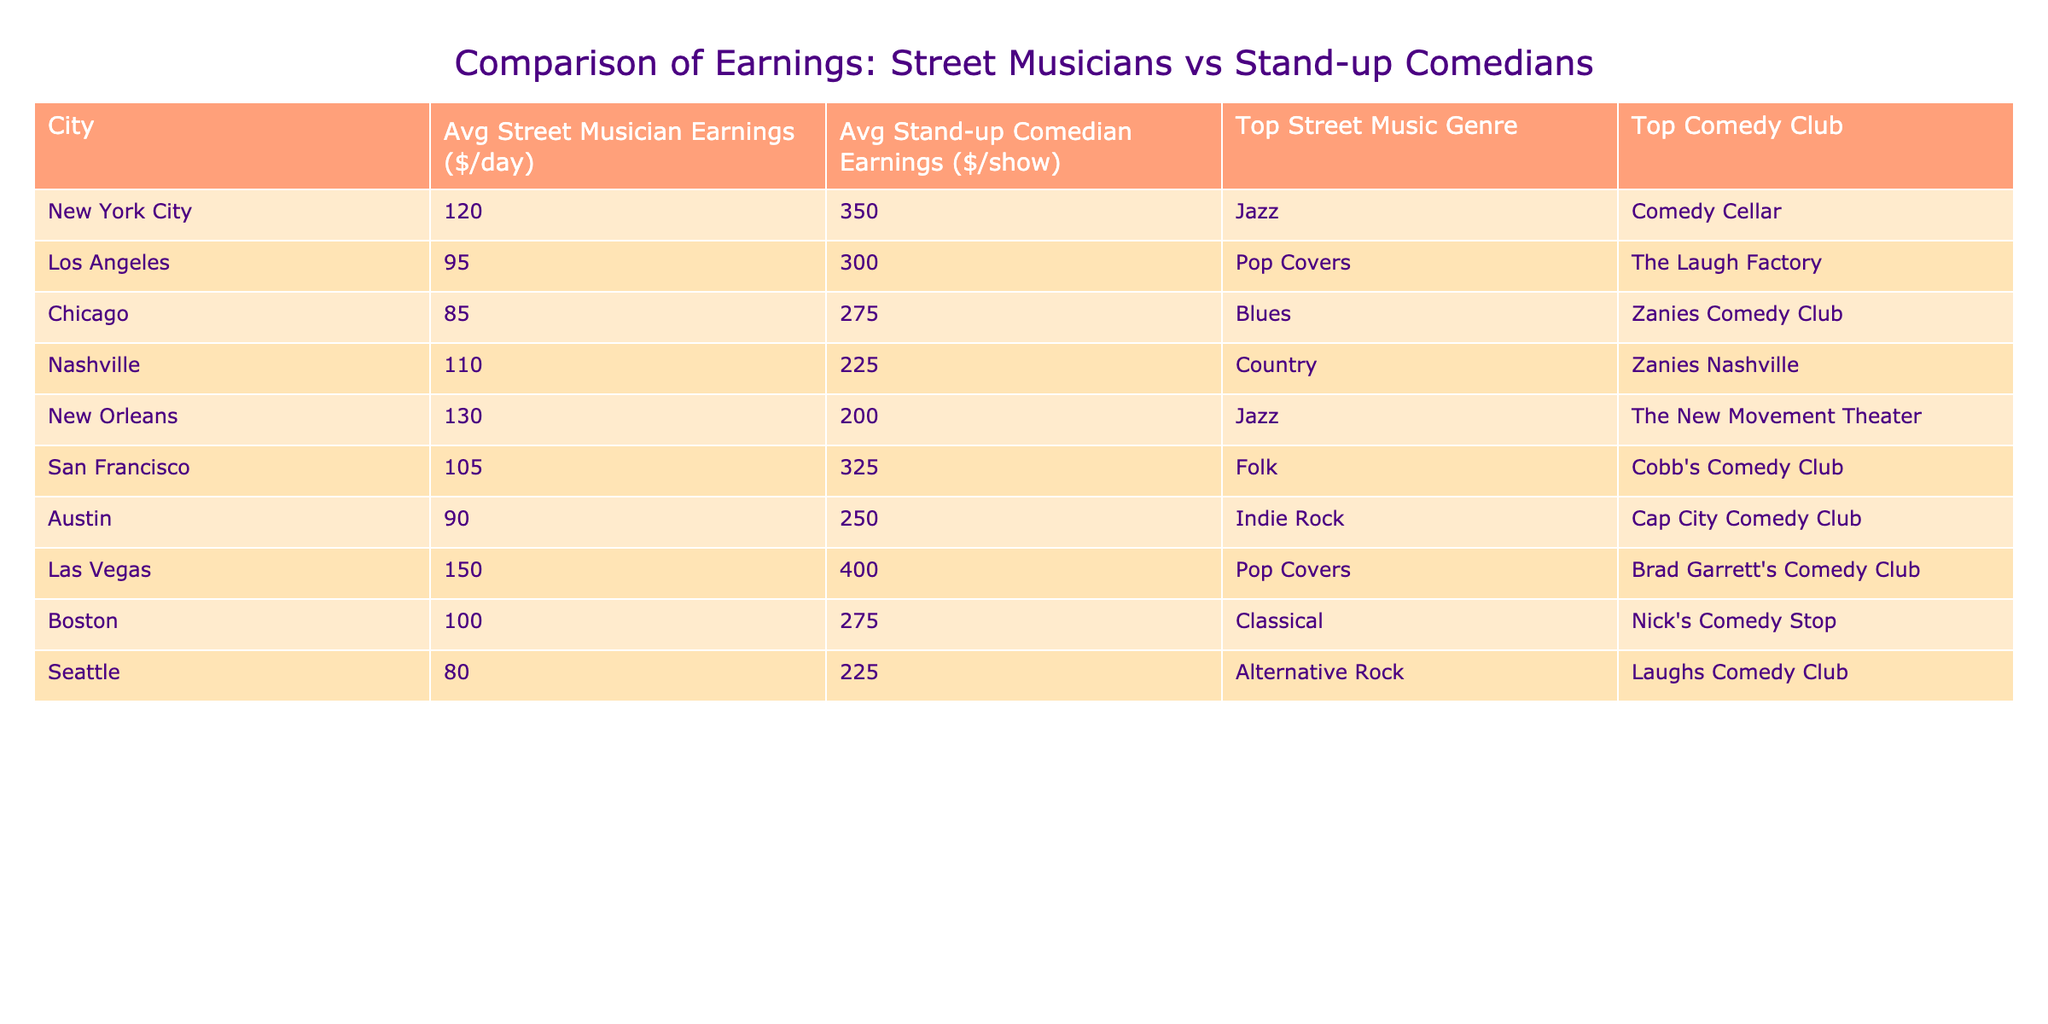What is the average earnings of street musicians in Los Angeles? According to the table, the average earnings of street musicians in Los Angeles is listed as $95 per day.
Answer: 95 Which city has the highest average earnings for stand-up comedians? By looking at the table, Las Vegas shows the highest average earnings for stand-up comedians at $400 per show.
Answer: 400 Is the top street music genre in New Orleans Jazz? The table indicates that the top street music genre in New Orleans is indeed Jazz, confirmed by the data listed.
Answer: Yes What is the difference in average earnings between street musicians in New York City and Chicago? The average earnings for street musicians in New York City is $120, and in Chicago, it is $85. The difference is 120 - 85 = 35.
Answer: 35 Which genre do street musicians in Nashville typically play? According to the table, the top street music genre in Nashville is Country, as stated in the data provided.
Answer: Country Calculate the average earnings of street musicians across all cities listed. Summing the average earnings: 120 + 95 + 85 + 110 + 130 + 105 + 90 + 150 + 100 + 80 = 1,025. There are 10 cities, so the average is 1,025 / 10 = 102.5.
Answer: 102.5 Is there a city where the average earnings of street musicians are greater than $100? The table shows that the average earnings of street musicians in New York City, Nashville, New Orleans, and Las Vegas are all above $100. Hence, the answer is affirmative.
Answer: Yes Which comedy club is associated with the top average stand-up comedian earnings? Looking at the table, Brad Garrett's Comedy Club in Las Vegas has the highest average stand-up comedian earnings of $400 per show, thus it is associated with the top earnings.
Answer: Brad Garrett's Comedy Club What is the relation between the top music genre for street musicians in San Francisco and Los Angeles? The table indicates that the top street music genre in San Francisco is Folk, while in Los Angeles, it is Pop Covers; they are different genres.
Answer: Different Calculate the total average earnings for street musicians and stand-up comedians combined in Chicago. For Chicago, street musicians earn an average of $85, while stand-up comedians earn $275. The total average earnings is 85 + 275 = 360.
Answer: 360 